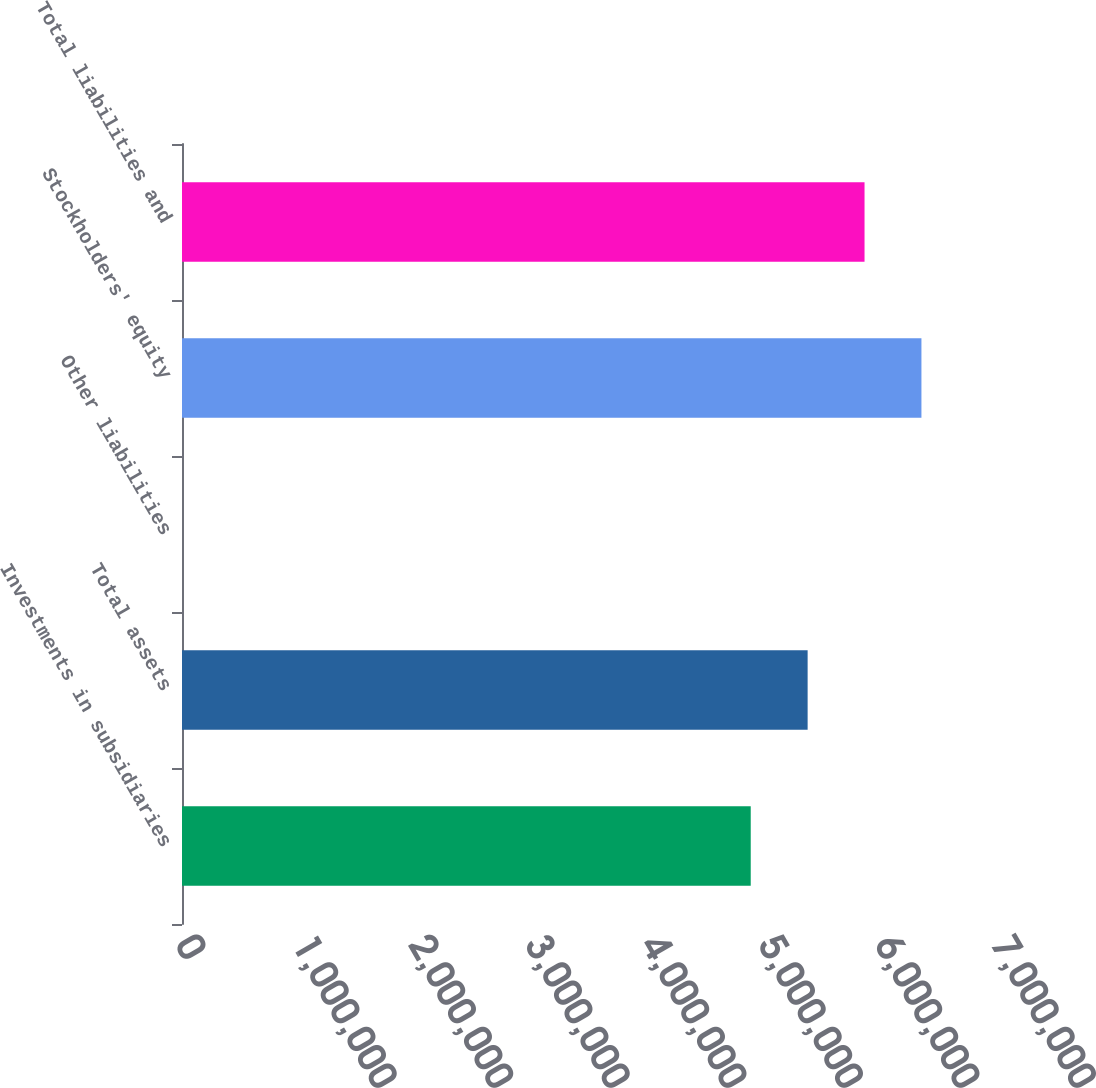Convert chart to OTSL. <chart><loc_0><loc_0><loc_500><loc_500><bar_chart><fcel>Investments in subsidiaries<fcel>Total assets<fcel>Other liabilities<fcel>Stockholders' equity<fcel>Total liabilities and<nl><fcel>4.87878e+06<fcel>5.36692e+06<fcel>8<fcel>6.34319e+06<fcel>5.85505e+06<nl></chart> 